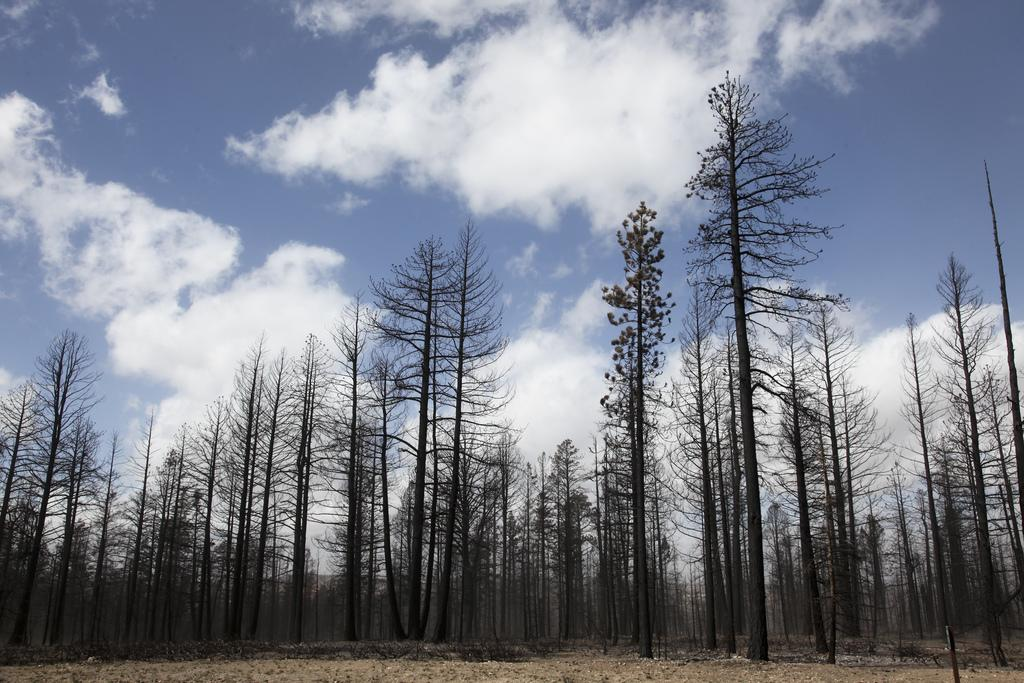What type of natural elements can be seen in the image? There are trees and clouds in the image. Can you describe the sky in the image? The sky in the image has clouds. What type of vegetable is growing on the sofa in the image? There is no sofa or vegetable present in the image. 